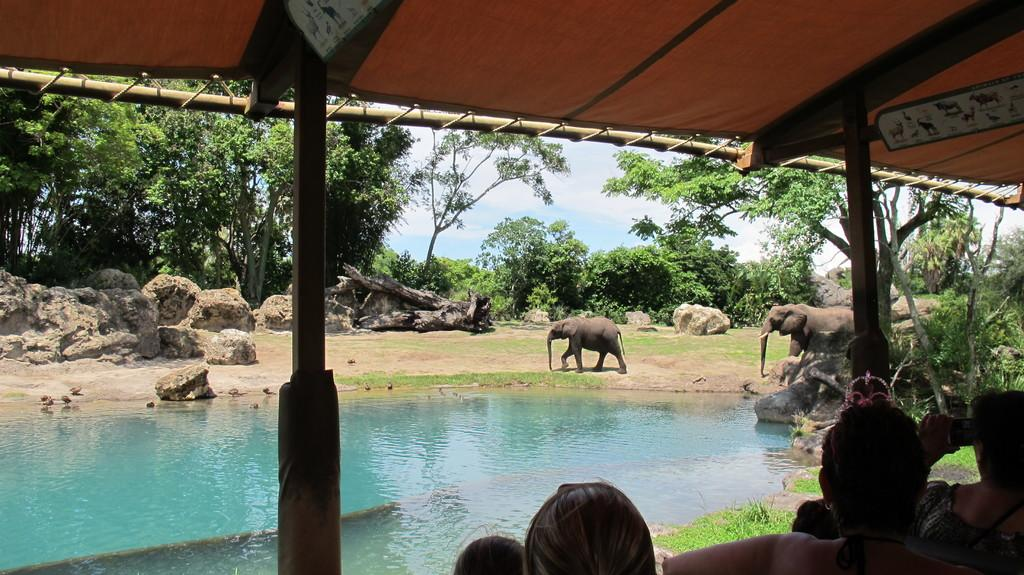How many elephants are in the image? There are two elephants in the image. What type of natural elements can be seen in the image? There are stones, trees, water, and grass in the image. What is visible celestial body is present in the image? The sky is visible in the image. What type of clothing can be seen on the people in the image? There are people wearing clothes in the image. What man-made structures can be seen in the image? There is a pole and a tent in the image. What type of cave can be seen in the image? There is no cave present in the image. What type of club is being used by the elephants in the image? There are no clubs or any elephants using them in the image. 